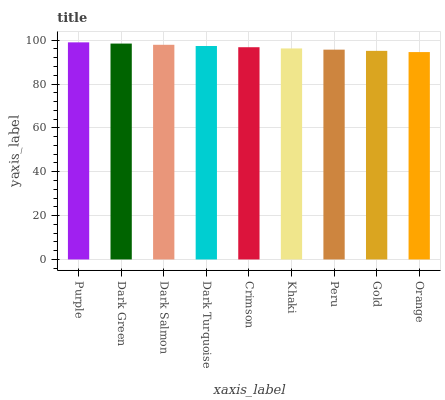Is Orange the minimum?
Answer yes or no. Yes. Is Purple the maximum?
Answer yes or no. Yes. Is Dark Green the minimum?
Answer yes or no. No. Is Dark Green the maximum?
Answer yes or no. No. Is Purple greater than Dark Green?
Answer yes or no. Yes. Is Dark Green less than Purple?
Answer yes or no. Yes. Is Dark Green greater than Purple?
Answer yes or no. No. Is Purple less than Dark Green?
Answer yes or no. No. Is Crimson the high median?
Answer yes or no. Yes. Is Crimson the low median?
Answer yes or no. Yes. Is Khaki the high median?
Answer yes or no. No. Is Orange the low median?
Answer yes or no. No. 